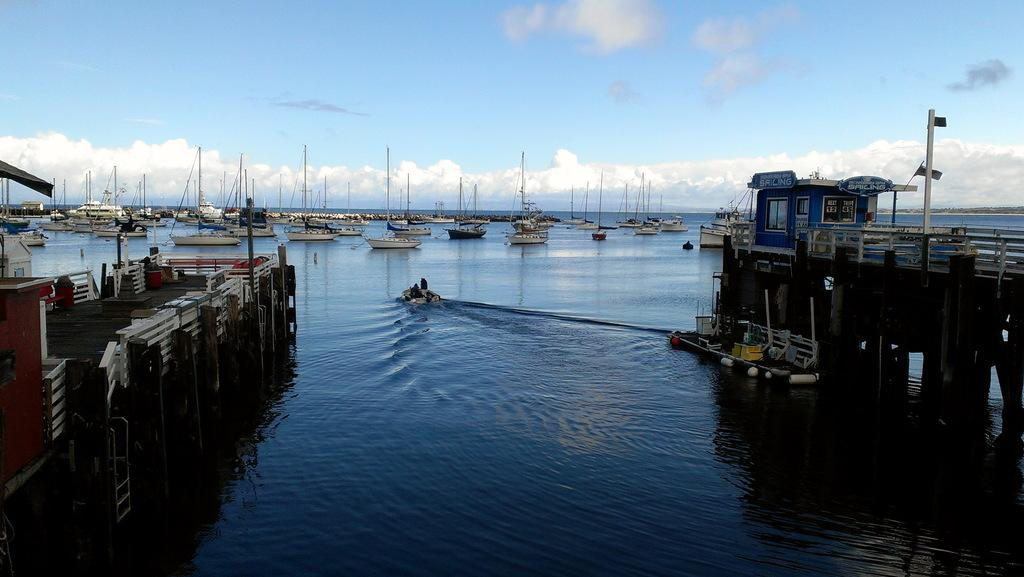What can be seen in the middle of the sea in the image? There are two paths in the middle of the sea in the image. What else is present on the sea in the image? There are boats on the sea. What is visible in the background of the image? The sky is visible in the background of the image. What type of park can be seen in the image? There is no park present in the image; it features two paths in the middle of the sea and boats on the sea. What time of day is it in the image, based on the belief that morning has a specific appearance? The image does not provide any information about the time of day, and beliefs about the appearance of morning cannot be used to determine the time in the image. 